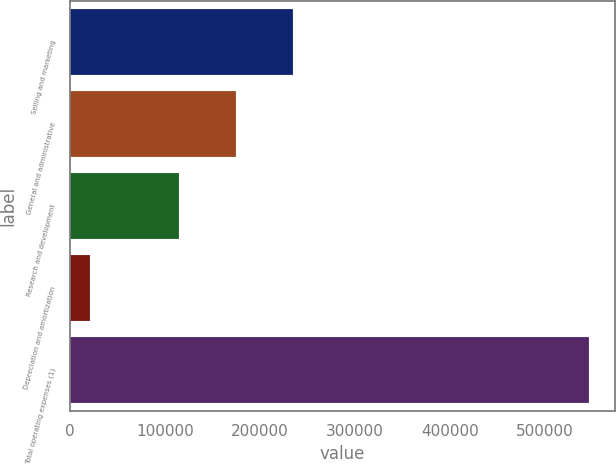<chart> <loc_0><loc_0><loc_500><loc_500><bar_chart><fcel>Selling and marketing<fcel>General and administrative<fcel>Research and development<fcel>Depreciation and amortization<fcel>Total operating expenses (1)<nl><fcel>235341<fcel>175093<fcel>115043<fcel>21057<fcel>546534<nl></chart> 